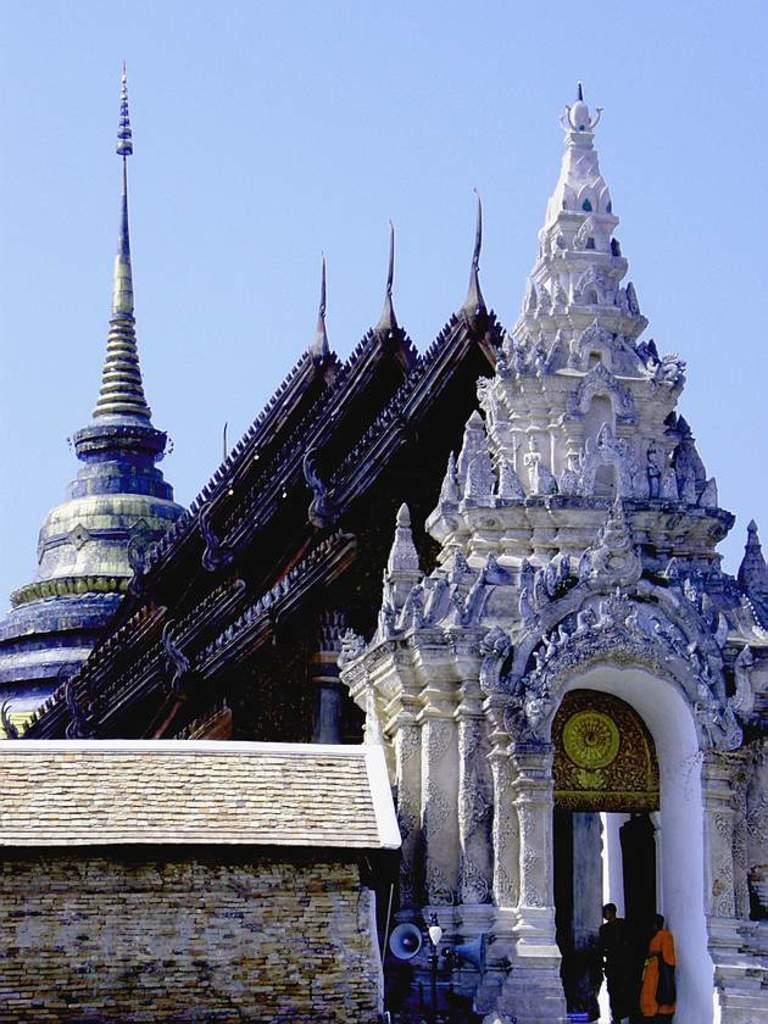Could you give a brief overview of what you see in this image? In this image we can see the buildings, there are some pillars, speaker and the wall, in the background, we can see the sky. 